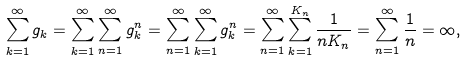<formula> <loc_0><loc_0><loc_500><loc_500>\sum _ { k = 1 } ^ { \infty } g _ { k } = \sum _ { k = 1 } ^ { \infty } \sum _ { n = 1 } ^ { \infty } g ^ { n } _ { k } = \sum _ { n = 1 } ^ { \infty } \sum _ { k = 1 } ^ { \infty } g ^ { n } _ { k } = \sum _ { n = 1 } ^ { \infty } \sum _ { k = 1 } ^ { K _ { n } } \frac { 1 } { n K _ { n } } = \sum _ { n = 1 } ^ { \infty } \frac { 1 } { n } = \infty ,</formula> 